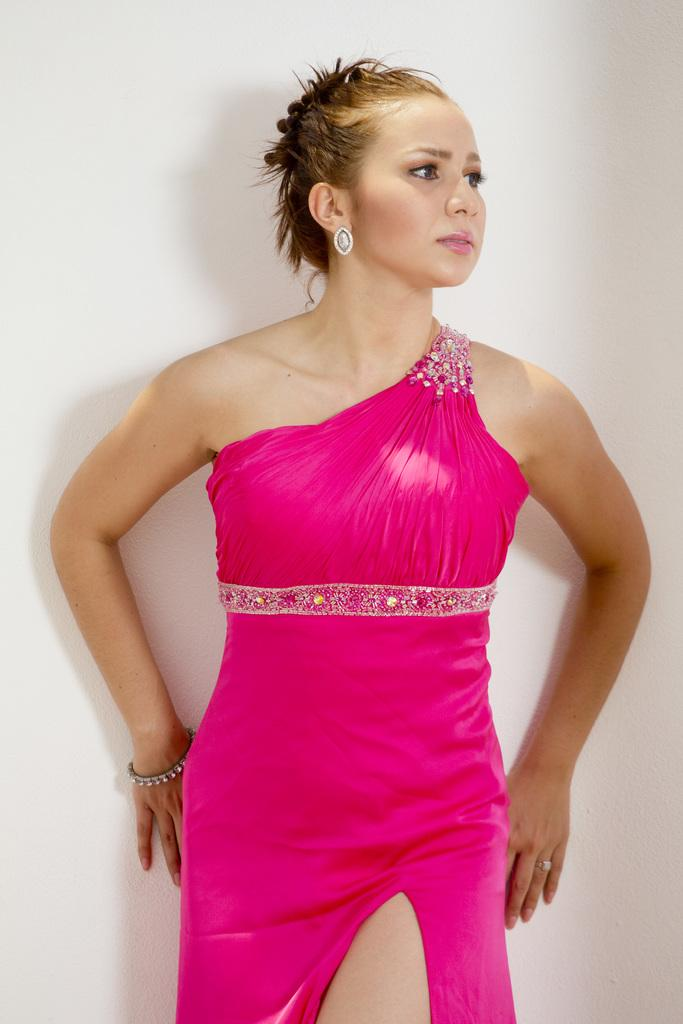Who is present in the image? There is a woman in the picture. What is the woman wearing? The woman is wearing a pink dress. In which direction is the woman looking? The woman is looking to the right side. What can be seen in the background of the image? There is a white color wall in the background of the image. What type of bait is the woman holding in the image? There is no bait present in the image; the woman is not holding anything. 